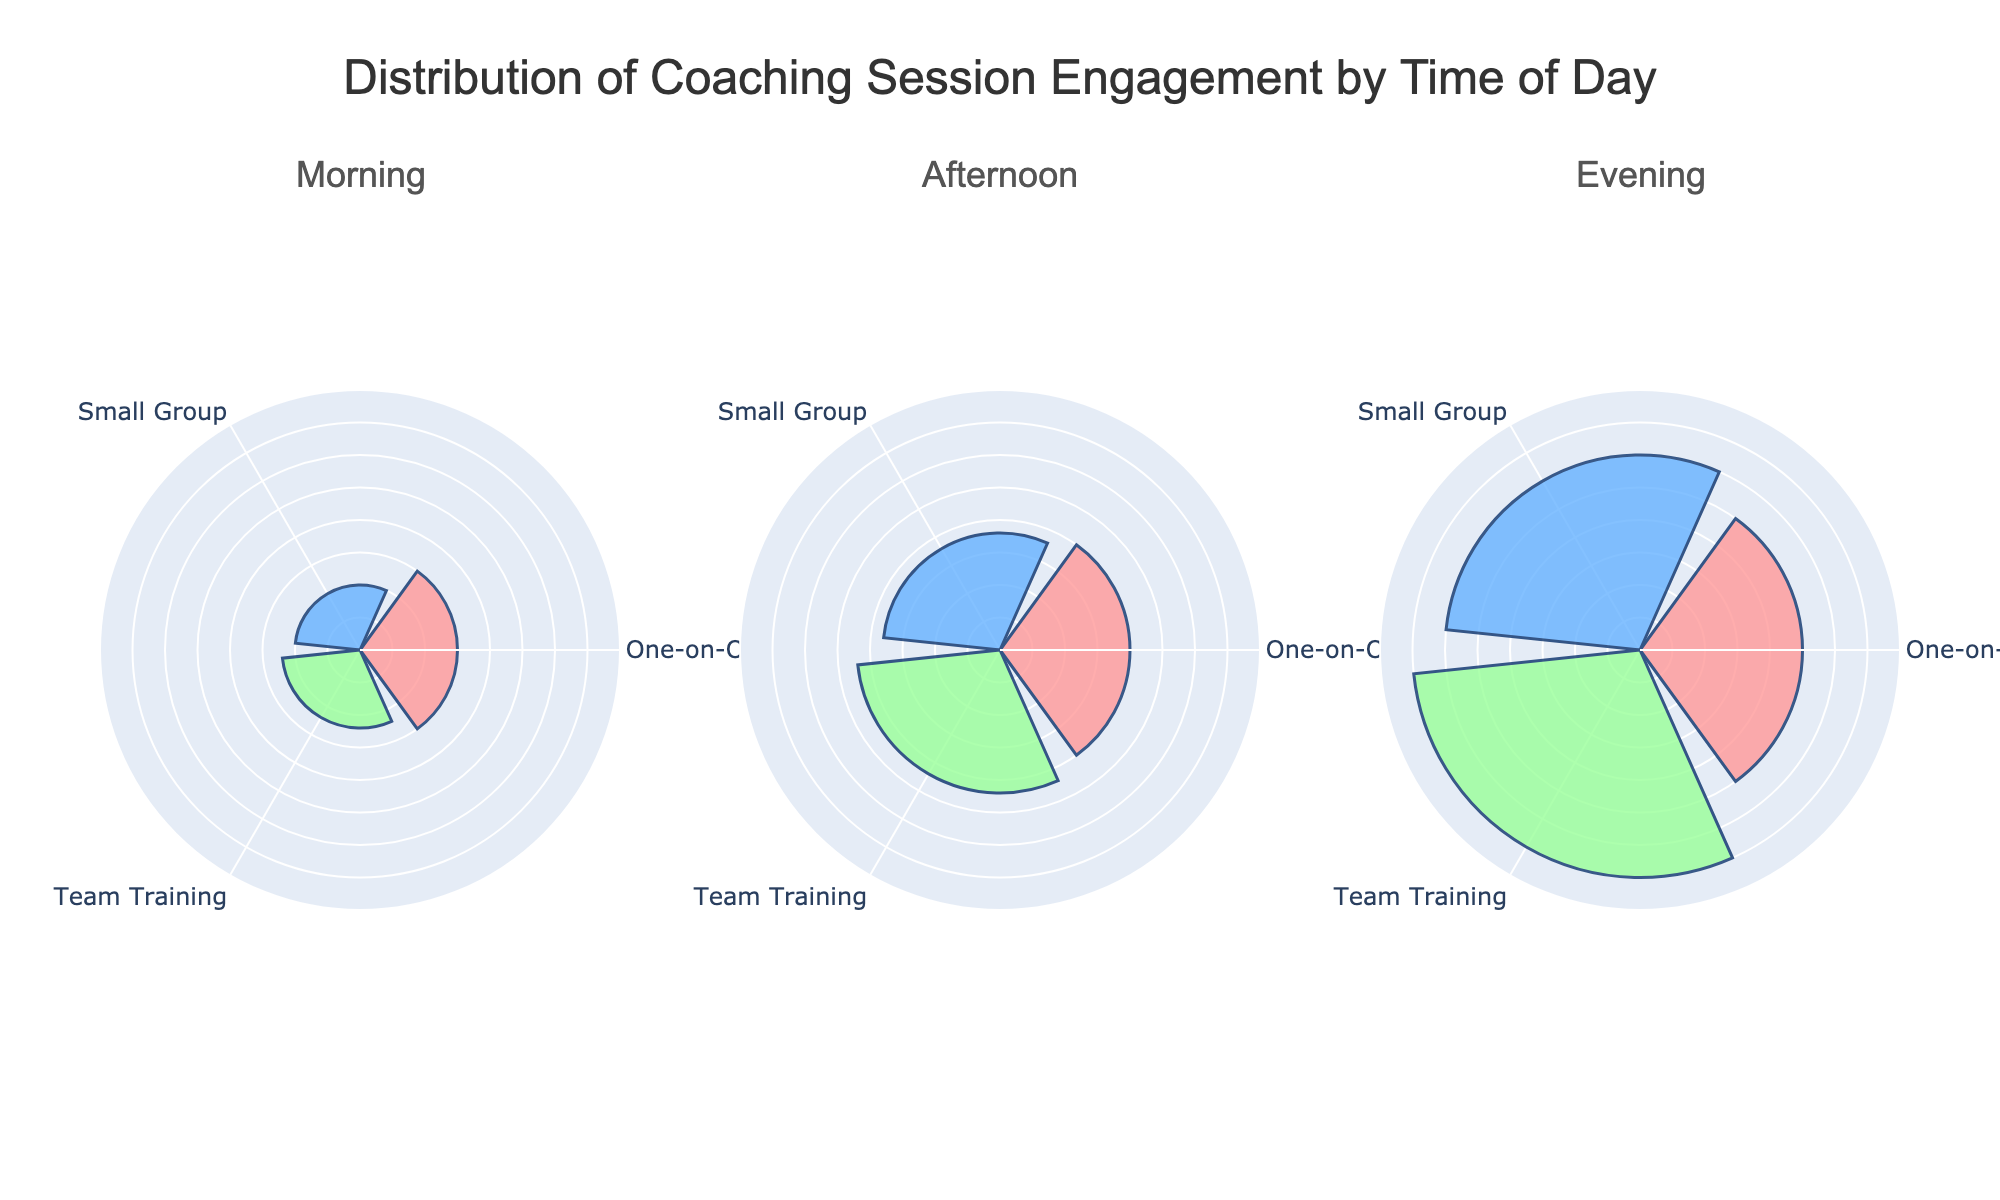What is the title of the figure? The title of the figure is displayed at the top and reads "Distribution of Coaching Session Engagement by Time of Day".
Answer: Distribution of Coaching Session Engagement by Time of Day Which time of day has the highest average engagement across all session types? To find the highest average engagement, calculate the average engagement for each time of day by summing the engagement values and dividing by the number of session types. Morning: (15+10+12)/3 = 37/3 = 12.3, Afternoon: (20+18+22)/3 = 60/3 = 20, Evening: (25+30+35)/3 = 90/3 = 30. Therefore, Evening has the highest average engagement.
Answer: Evening What is the engagement value for One-on-One sessions in the Morning? In the Morning subplot, the engagement value for the One-on-One session is shown as 15.
Answer: 15 How does the engagement for Small Group sessions in the Evening compare to the engagement for Team Training sessions in the Afternoon? The engagement for Small Group sessions in the Evening is 30, while for Team Training sessions in the Afternoon it is 22. Comparing these values shows that the Evening Small Group sessions have higher engagement.
Answer: Small Group sessions in the Evening have higher engagement Among all session types, which one has the lowest engagement in the Afternoon? In the Afternoon subplot, One-on-One, Small Group, and Team Training sessions have engagements of 20, 18, and 22 respectively. Small Group sessions have the lowest engagement of 18.
Answer: Small Group What is the difference in engagement between Team Training sessions in the Morning and Evening? The engagement for Team Training sessions in the Morning is 12, while in the Evening it is 35. The difference is 35 - 12 = 23.
Answer: 23 Rank the session types in the Morning from highest to lowest in terms of engagement. The engagements for One-on-One, Small Group, and Team Training sessions in the Morning are 15, 10, and 12 respectively. Ranking from highest to lowest: One-on-One (15), Team Training (12), Small Group (10).
Answer: One-on-One, Team Training, Small Group What is the range of engagement values in the Afternoon? The engagement values in the Afternoon are 20, 18, and 22. The range is the difference between the highest and lowest values, 22 - 18 = 4.
Answer: 4 Which session type experiences the greatest increase in engagement from Morning to Evening? To determine the greatest increase, calculate the differences for each session type from Morning to Evening. One-on-One: 25 - 15 = 10, Small Group: 30 - 10 = 20, Team Training: 35 - 12 = 23. Team Training experiences the greatest increase of 23.
Answer: Team Training What is the total engagement for all session types in the Evening? Sum the engagement values for One-on-One, Small Group, and Team Training sessions in the Evening: 25 + 30 + 35 = 90.
Answer: 90 